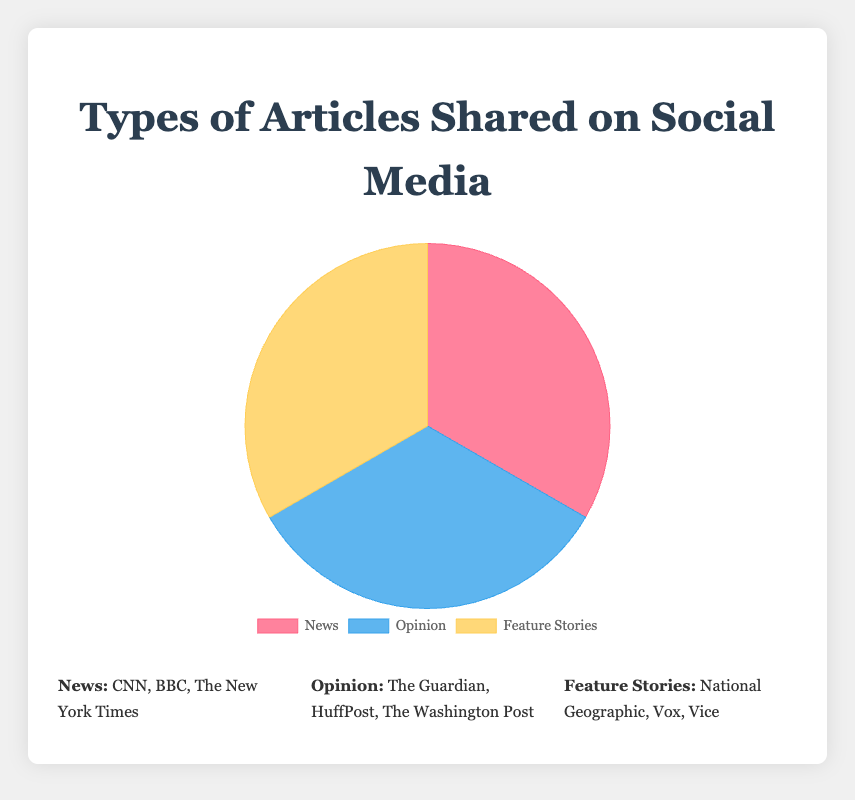What percentage of all articles shared are News articles? The chart labels the three types of articles and the data points add up to 100%. The pie chart segment for News labels 100 * (40% from CNN + 35% from BBC + 25% from The New York Times) = 100%.
Answer: 100% Which type of article has the highest percentage shared from a single source? By looking at the data points, Feature Stories have the highest percentage shared from a single source, with National Geographic contributing 50%.
Answer: Feature Stories (National Geographic at 50%) What is the combined percentage of articles shared from The Guardian and Vox? The Guardian contributes 45% to Opinion articles and Vox contributes 30% to Feature Stories. Adding these together, 45% + 30% = 75%.
Answer: 75% How does the percentage of Opinion articles shared by HuffPost compare to the percentage by The New York Times? HuffPost contributes 30% to Opinion articles while The New York Times contributes 25% to News articles. Comparing them: 30% (HuffPost) is greater than 25% (The New York Times).
Answer: 30% > 25% Which source contributes the least to its article type, and by what percentage? The smallest percentage contribution is from Vice for Feature Stories, which is 20%.
Answer: Vice at 20% Among all the sources listed, which has the highest aggregated percentage across all types of articles? National Geographic contributes 50% to Feature Stories, but other sources do not report contributions across multiple types. Therefore, National Geographic's 50% remains the highest aggregated percentage from a single source.
Answer: National Geographic at 50% Is the total percentage of News articles shared by CNN and BBC greater than that of Feature Stories shared by Vox and Vice? If so, by how much? Sum for CNN and BBC is 40% + 35% = 75%. Sum for Vox and Vice is 30% + 20% = 50%. The difference is 75% - 50% = 25%.
Answer: Yes, by 25% What is the difference in percentage between the sources with the highest and the lowest contributions? The highest single-source percentage is National Geographic with 50%, and the lowest is Vice with 20%. The difference is 50% - 20% = 30%.
Answer: 30% What is the percentage of articles shared by sources contributing less than 30%? Analyzing data points: The New York Times (25%), The Washington Post (25%), and Vice (20%) all contribute less than 30%. Adding these: 25% + 25% + 20% = 70%.
Answer: 70% 